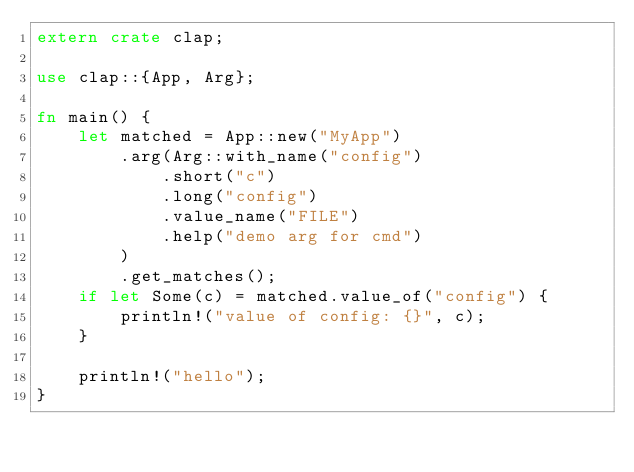Convert code to text. <code><loc_0><loc_0><loc_500><loc_500><_Rust_>extern crate clap;

use clap::{App, Arg};

fn main() {
    let matched = App::new("MyApp")
        .arg(Arg::with_name("config")
            .short("c")
            .long("config")
            .value_name("FILE")
            .help("demo arg for cmd")
        )
        .get_matches();
    if let Some(c) = matched.value_of("config") {
        println!("value of config: {}", c);
    }

    println!("hello");
}
</code> 